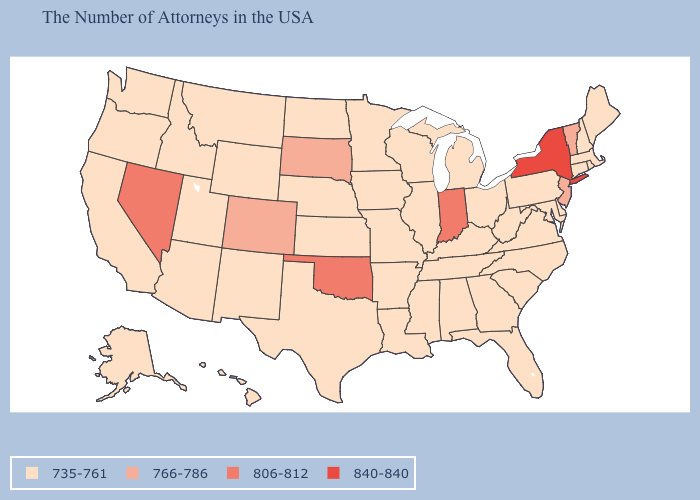What is the lowest value in states that border Mississippi?
Concise answer only. 735-761. Does Arkansas have a lower value than New York?
Quick response, please. Yes. What is the value of New Hampshire?
Short answer required. 735-761. What is the lowest value in the USA?
Quick response, please. 735-761. What is the value of Wisconsin?
Be succinct. 735-761. Name the states that have a value in the range 766-786?
Quick response, please. Vermont, New Jersey, South Dakota, Colorado. What is the value of Florida?
Quick response, please. 735-761. Which states have the lowest value in the USA?
Short answer required. Maine, Massachusetts, Rhode Island, New Hampshire, Connecticut, Delaware, Maryland, Pennsylvania, Virginia, North Carolina, South Carolina, West Virginia, Ohio, Florida, Georgia, Michigan, Kentucky, Alabama, Tennessee, Wisconsin, Illinois, Mississippi, Louisiana, Missouri, Arkansas, Minnesota, Iowa, Kansas, Nebraska, Texas, North Dakota, Wyoming, New Mexico, Utah, Montana, Arizona, Idaho, California, Washington, Oregon, Alaska, Hawaii. What is the value of Hawaii?
Answer briefly. 735-761. What is the value of Indiana?
Quick response, please. 806-812. What is the highest value in the South ?
Quick response, please. 806-812. Does Delaware have the same value as Alabama?
Short answer required. Yes. What is the highest value in states that border Texas?
Short answer required. 806-812. Among the states that border Connecticut , does New York have the lowest value?
Answer briefly. No. 